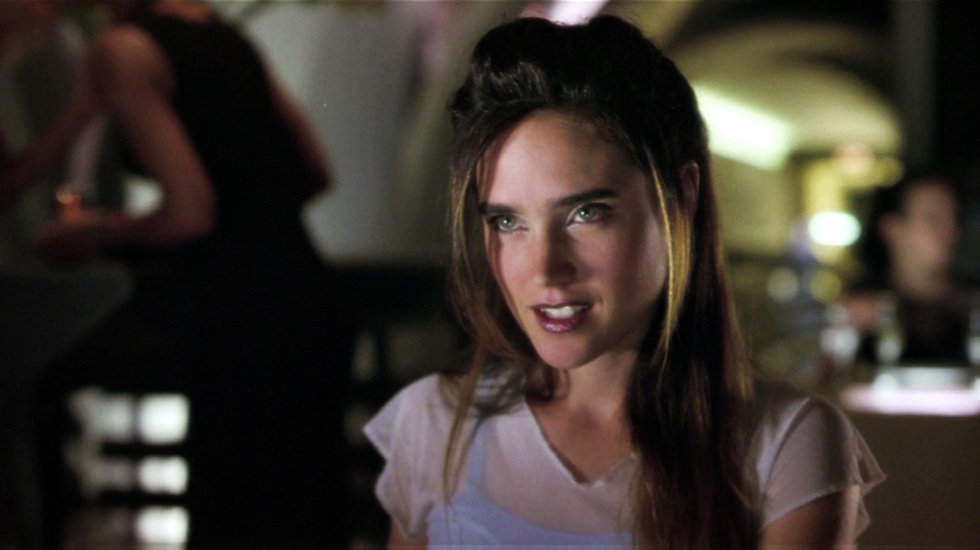Could you infer what time of day it might be in this image? While it is not possible to determine the exact time of day from the image alone, several clues suggest it could be evening. The low, warm lighting and the fact that it's a social scene typically associated with nighttime leisure suggest that the photo was likely taken in the evening or at night. 